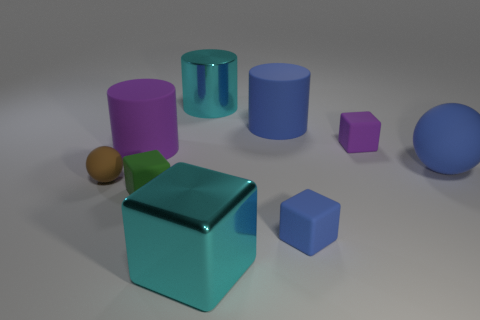Add 1 rubber blocks. How many objects exist? 10 Subtract all spheres. How many objects are left? 7 Subtract all cyan shiny cylinders. Subtract all large cyan cylinders. How many objects are left? 7 Add 6 purple cylinders. How many purple cylinders are left? 7 Add 5 large yellow spheres. How many large yellow spheres exist? 5 Subtract 0 gray cubes. How many objects are left? 9 